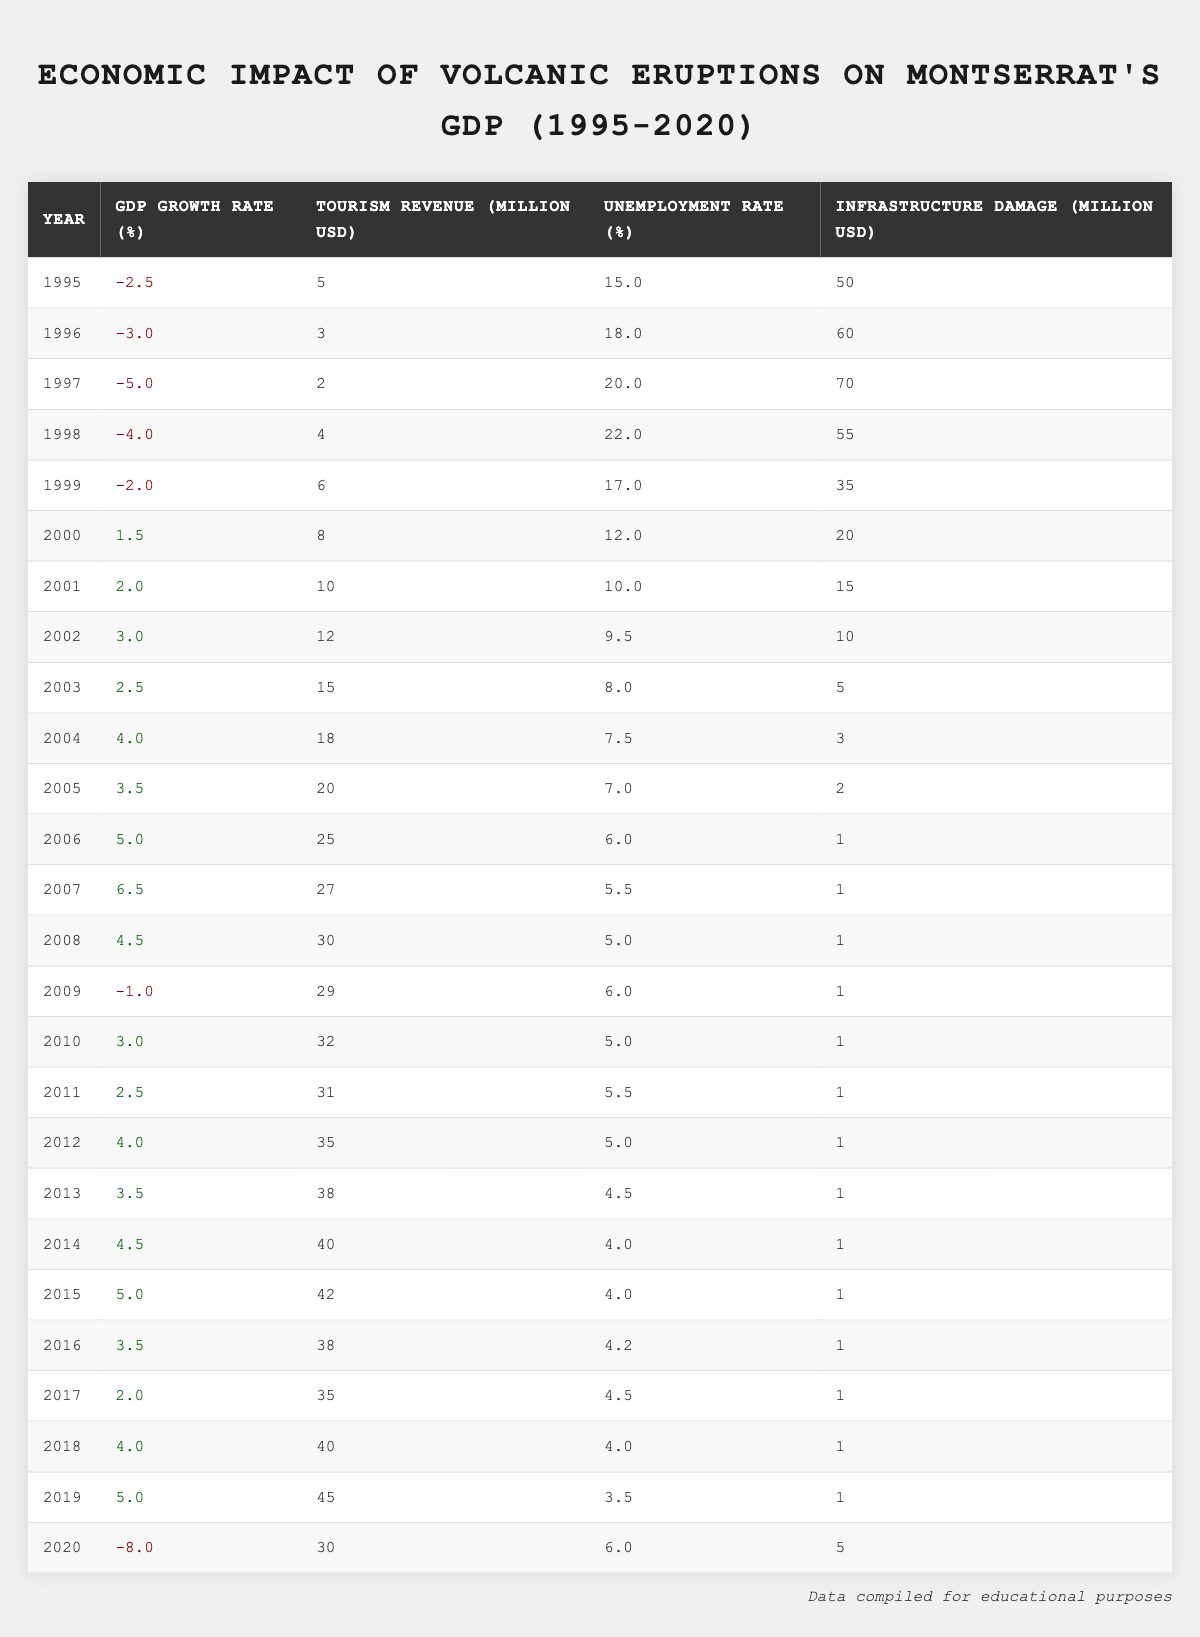What was the GDP growth rate in 1995? In the table, the GDP growth rate for the year 1995 is directly listed as -2.5%
Answer: -2.5% What was the highest tourism revenue recorded during this period? The year with the highest tourism revenue is 2019, with a revenue of 45 million USD as shown in the table
Answer: 45 million USD What was the unemployment rate in 2006? The unemployment rate for the year 2006 is stated in the table as 6.0%
Answer: 6.0% Which year had the most significant infrastructure damage? By examining the table, 1997 shows the highest infrastructure damage at 70 million USD
Answer: 70 million USD What was the average GDP growth rate from 2000 to 2007? The GDP growth rates for 2000 to 2007 are 1.5, 2.0, 3.0, 2.5, 4.0, 3.5, and 5.0. Summing these gives 22.5, and dividing by 7 gives an average of 3.21%
Answer: 3.21% Was there an improvement in tourism revenue from 1995 to 2020? The table shows tourism revenue in 1995 at 5 million USD and in 2020 at 30 million USD, indicating an overall increase, thus the answer is yes
Answer: Yes Which year saw the largest drop in GDP growth rate? In the table, 2020 shows a significant decrease with a GDP growth rate of -8.0%. This is the most negative rate in the dataset
Answer: -8.0% How did the unemployment rate trend from 1995 to 2020? In reviewing the years, the unemployment rate decreased from 15.0% in 1995 to 6.0% in 2010, then fluctuated, with a final rate of 6.0% in 2020
Answer: It decreased then fluctuated What is the total infrastructure damage reported from 1995 to 2020? The total infrastructure damage is the sum of yearly damages: 50 + 60 + 70 + 55 + 35 + 20 + 15 + 10 + 5 + 3 + 2 + 1 + 1 + 1 + 1 + 1 + 1 + 1 + 1 + 5 = 317 million USD
Answer: 317 million USD Did the GDP growth rate ever become positive after 1999? The data shows positive GDP growth rates starting in the year 2000, confirming that it did become positive after 1999
Answer: Yes 